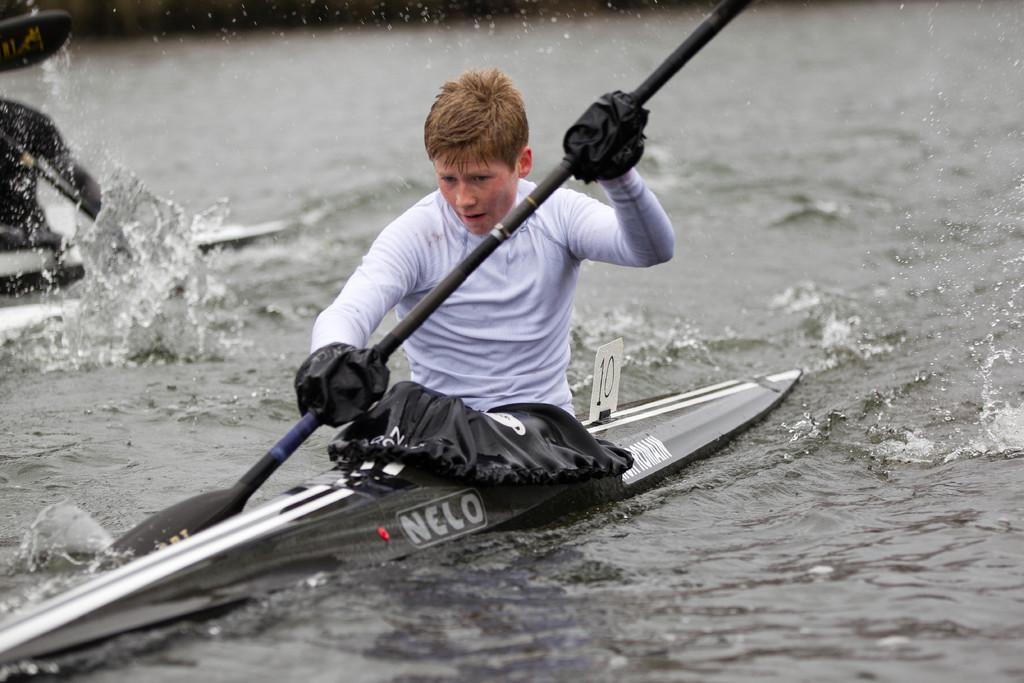What is the main subject in the foreground of the image? There is a person in a sea kayak vehicle in the foreground of the image. Can you describe the second person in the image? There is another person in a sea kayak vehicle, but their face is not visible. What type of hall can be seen in the background of the image? There is no hall visible in the image; it features two people in sea kayak vehicles. Can you describe the beetle that is crawling on the person's shoulder in the image? There is no beetle present in the image; it only shows two people in sea kayak vehicles. 